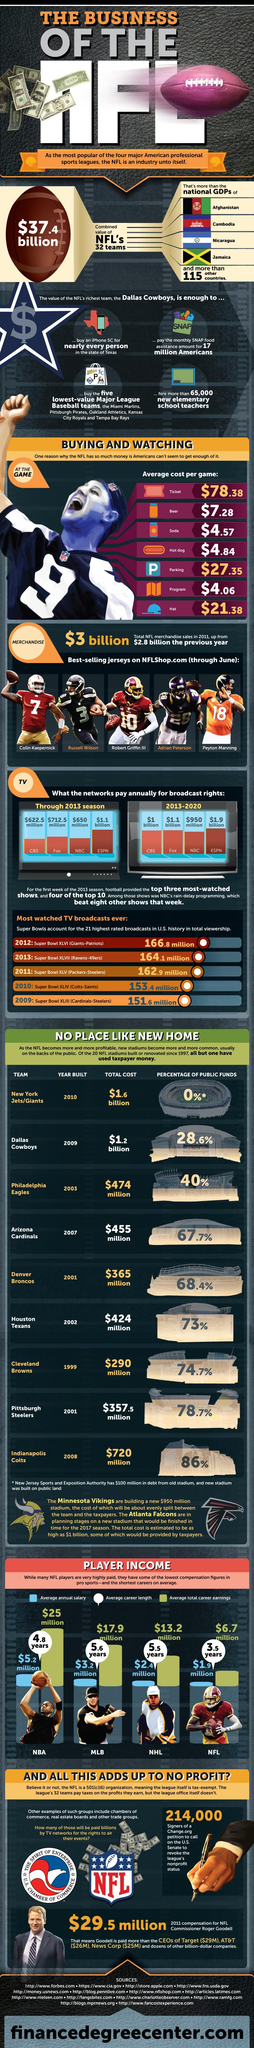Draw attention to some important aspects in this diagram. In the period between 2013 and 2020, Fox paid an annual sum of $1.1 billion for the rights to broadcast a specific event or series. During the period of 2013 to 2020, NBC paid less than $1 billion annually for broadcast rights. In 2013, Fox paid the second highest amount annually for broadcast rights. The average career length of an NHL player is 5.5 years, indicating that the majority of players do not have successful long-term careers in the league. In the 2013 season, ESPN received more than $1 billion in annual broadcast rights, making it the network that paid the most for sports programming. 